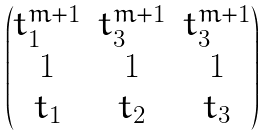<formula> <loc_0><loc_0><loc_500><loc_500>\begin{pmatrix} t _ { 1 } ^ { m + 1 } & t _ { 3 } ^ { m + 1 } & t _ { 3 } ^ { m + 1 } \\ 1 & 1 & 1 \\ t _ { 1 } & t _ { 2 } & t _ { 3 } \end{pmatrix}</formula> 